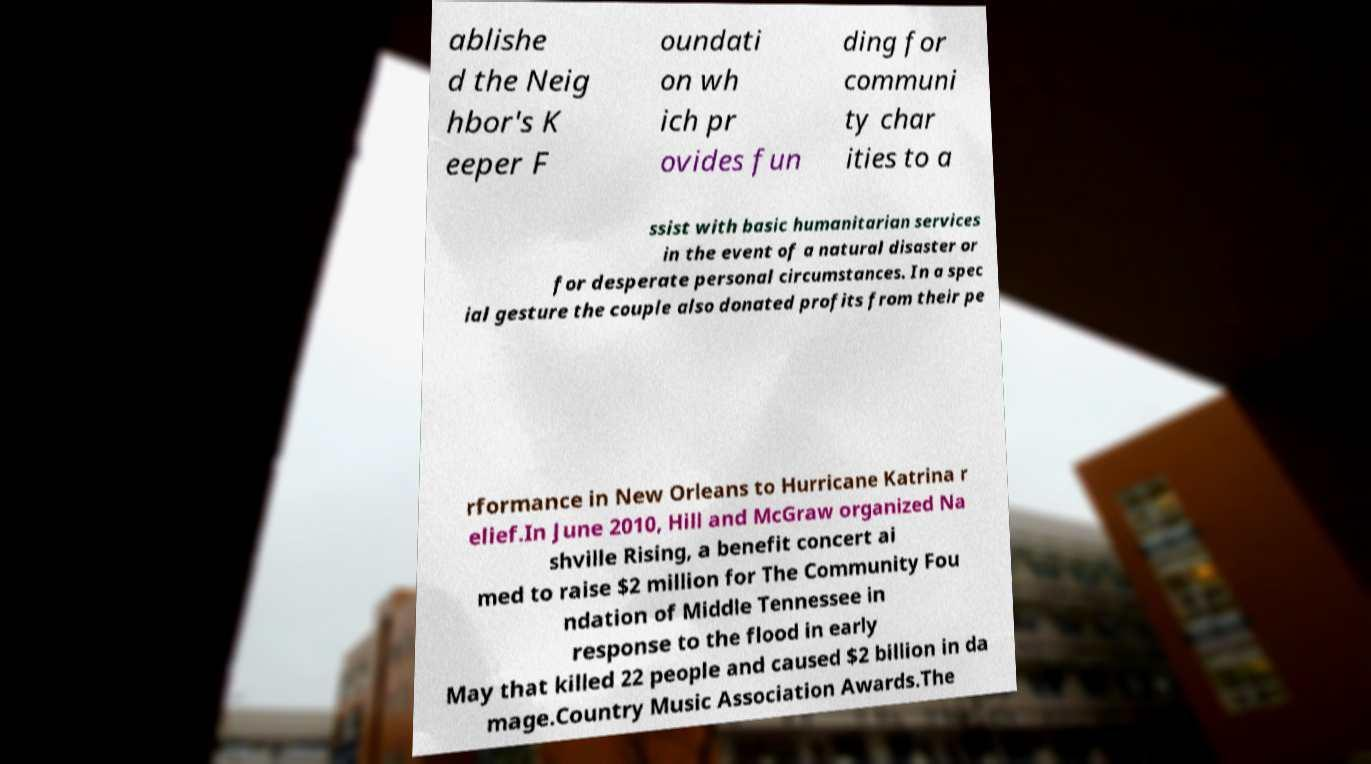Can you read and provide the text displayed in the image?This photo seems to have some interesting text. Can you extract and type it out for me? ablishe d the Neig hbor's K eeper F oundati on wh ich pr ovides fun ding for communi ty char ities to a ssist with basic humanitarian services in the event of a natural disaster or for desperate personal circumstances. In a spec ial gesture the couple also donated profits from their pe rformance in New Orleans to Hurricane Katrina r elief.In June 2010, Hill and McGraw organized Na shville Rising, a benefit concert ai med to raise $2 million for The Community Fou ndation of Middle Tennessee in response to the flood in early May that killed 22 people and caused $2 billion in da mage.Country Music Association Awards.The 